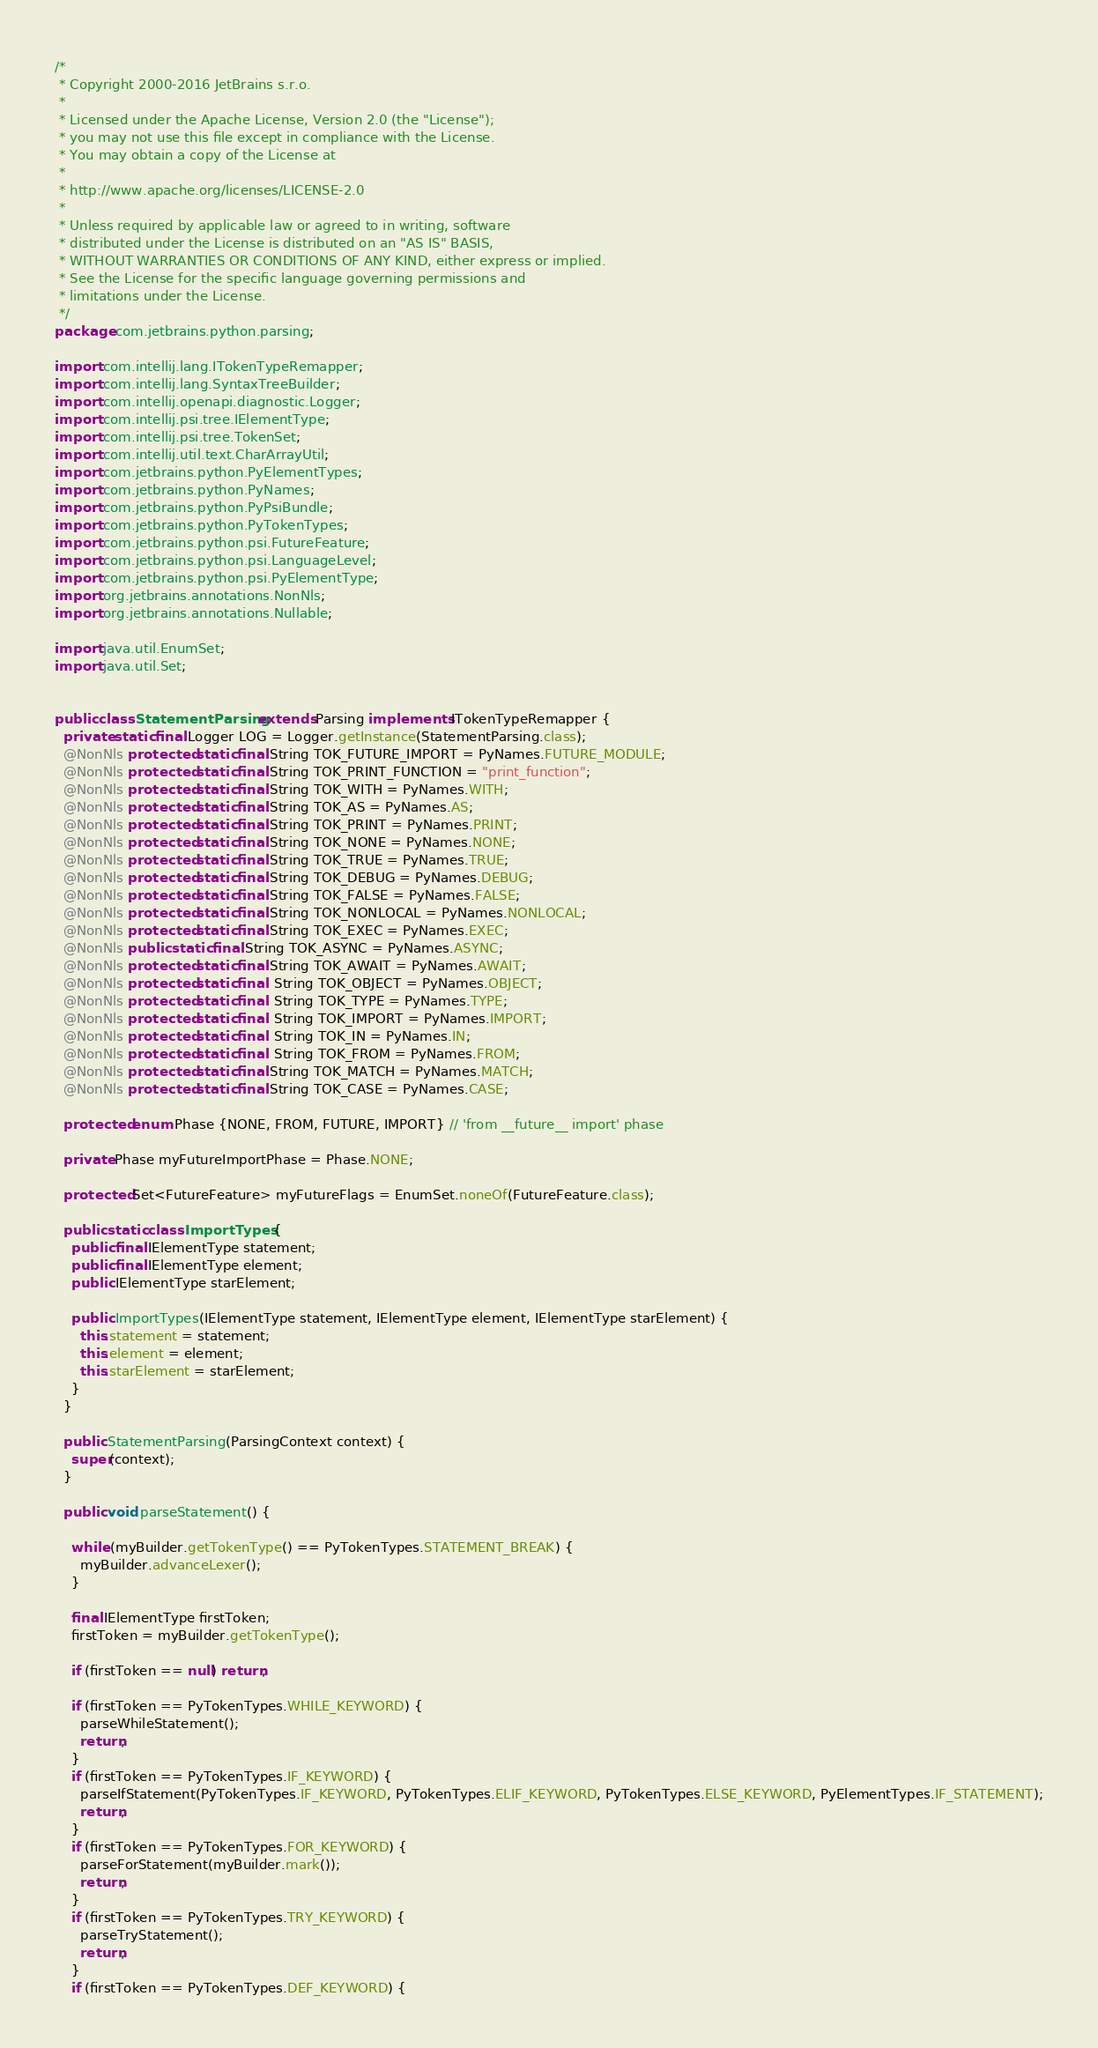Convert code to text. <code><loc_0><loc_0><loc_500><loc_500><_Java_>/*
 * Copyright 2000-2016 JetBrains s.r.o.
 *
 * Licensed under the Apache License, Version 2.0 (the "License");
 * you may not use this file except in compliance with the License.
 * You may obtain a copy of the License at
 *
 * http://www.apache.org/licenses/LICENSE-2.0
 *
 * Unless required by applicable law or agreed to in writing, software
 * distributed under the License is distributed on an "AS IS" BASIS,
 * WITHOUT WARRANTIES OR CONDITIONS OF ANY KIND, either express or implied.
 * See the License for the specific language governing permissions and
 * limitations under the License.
 */
package com.jetbrains.python.parsing;

import com.intellij.lang.ITokenTypeRemapper;
import com.intellij.lang.SyntaxTreeBuilder;
import com.intellij.openapi.diagnostic.Logger;
import com.intellij.psi.tree.IElementType;
import com.intellij.psi.tree.TokenSet;
import com.intellij.util.text.CharArrayUtil;
import com.jetbrains.python.PyElementTypes;
import com.jetbrains.python.PyNames;
import com.jetbrains.python.PyPsiBundle;
import com.jetbrains.python.PyTokenTypes;
import com.jetbrains.python.psi.FutureFeature;
import com.jetbrains.python.psi.LanguageLevel;
import com.jetbrains.python.psi.PyElementType;
import org.jetbrains.annotations.NonNls;
import org.jetbrains.annotations.Nullable;

import java.util.EnumSet;
import java.util.Set;


public class StatementParsing extends Parsing implements ITokenTypeRemapper {
  private static final Logger LOG = Logger.getInstance(StatementParsing.class);
  @NonNls protected static final String TOK_FUTURE_IMPORT = PyNames.FUTURE_MODULE;
  @NonNls protected static final String TOK_PRINT_FUNCTION = "print_function";
  @NonNls protected static final String TOK_WITH = PyNames.WITH;
  @NonNls protected static final String TOK_AS = PyNames.AS;
  @NonNls protected static final String TOK_PRINT = PyNames.PRINT;
  @NonNls protected static final String TOK_NONE = PyNames.NONE;
  @NonNls protected static final String TOK_TRUE = PyNames.TRUE;
  @NonNls protected static final String TOK_DEBUG = PyNames.DEBUG;
  @NonNls protected static final String TOK_FALSE = PyNames.FALSE;
  @NonNls protected static final String TOK_NONLOCAL = PyNames.NONLOCAL;
  @NonNls protected static final String TOK_EXEC = PyNames.EXEC;
  @NonNls public static final String TOK_ASYNC = PyNames.ASYNC;
  @NonNls protected static final String TOK_AWAIT = PyNames.AWAIT;
  @NonNls protected static final  String TOK_OBJECT = PyNames.OBJECT;
  @NonNls protected static final  String TOK_TYPE = PyNames.TYPE;
  @NonNls protected static final  String TOK_IMPORT = PyNames.IMPORT;
  @NonNls protected static final  String TOK_IN = PyNames.IN;
  @NonNls protected static final  String TOK_FROM = PyNames.FROM;
  @NonNls protected static final String TOK_MATCH = PyNames.MATCH;
  @NonNls protected static final String TOK_CASE = PyNames.CASE;

  protected enum Phase {NONE, FROM, FUTURE, IMPORT} // 'from __future__ import' phase

  private Phase myFutureImportPhase = Phase.NONE;

  protected Set<FutureFeature> myFutureFlags = EnumSet.noneOf(FutureFeature.class);

  public static class ImportTypes {
    public final IElementType statement;
    public final IElementType element;
    public IElementType starElement;

    public ImportTypes(IElementType statement, IElementType element, IElementType starElement) {
      this.statement = statement;
      this.element = element;
      this.starElement = starElement;
    }
  }

  public StatementParsing(ParsingContext context) {
    super(context);
  }

  public void parseStatement() {

    while (myBuilder.getTokenType() == PyTokenTypes.STATEMENT_BREAK) {
      myBuilder.advanceLexer();
    }

    final IElementType firstToken;
    firstToken = myBuilder.getTokenType();

    if (firstToken == null) return;

    if (firstToken == PyTokenTypes.WHILE_KEYWORD) {
      parseWhileStatement();
      return;
    }
    if (firstToken == PyTokenTypes.IF_KEYWORD) {
      parseIfStatement(PyTokenTypes.IF_KEYWORD, PyTokenTypes.ELIF_KEYWORD, PyTokenTypes.ELSE_KEYWORD, PyElementTypes.IF_STATEMENT);
      return;
    }
    if (firstToken == PyTokenTypes.FOR_KEYWORD) {
      parseForStatement(myBuilder.mark());
      return;
    }
    if (firstToken == PyTokenTypes.TRY_KEYWORD) {
      parseTryStatement();
      return;
    }
    if (firstToken == PyTokenTypes.DEF_KEYWORD) {</code> 